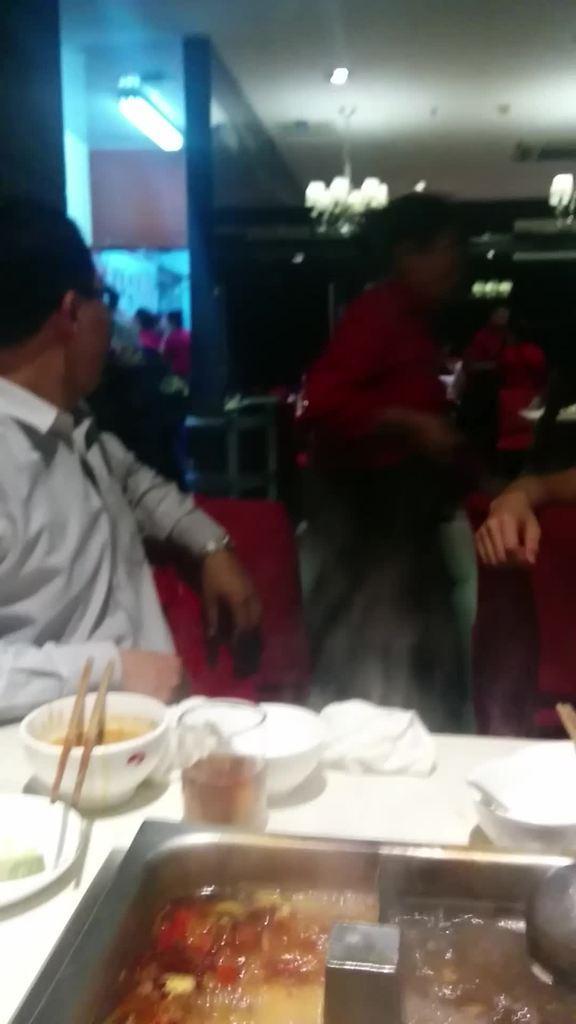Could you give a brief overview of what you see in this image? This person sitting on chair and this person standing,we can see bowls,ticks,container,food and objects on the table. Right side of the image we can see person hand. Background we can see lights and people. 